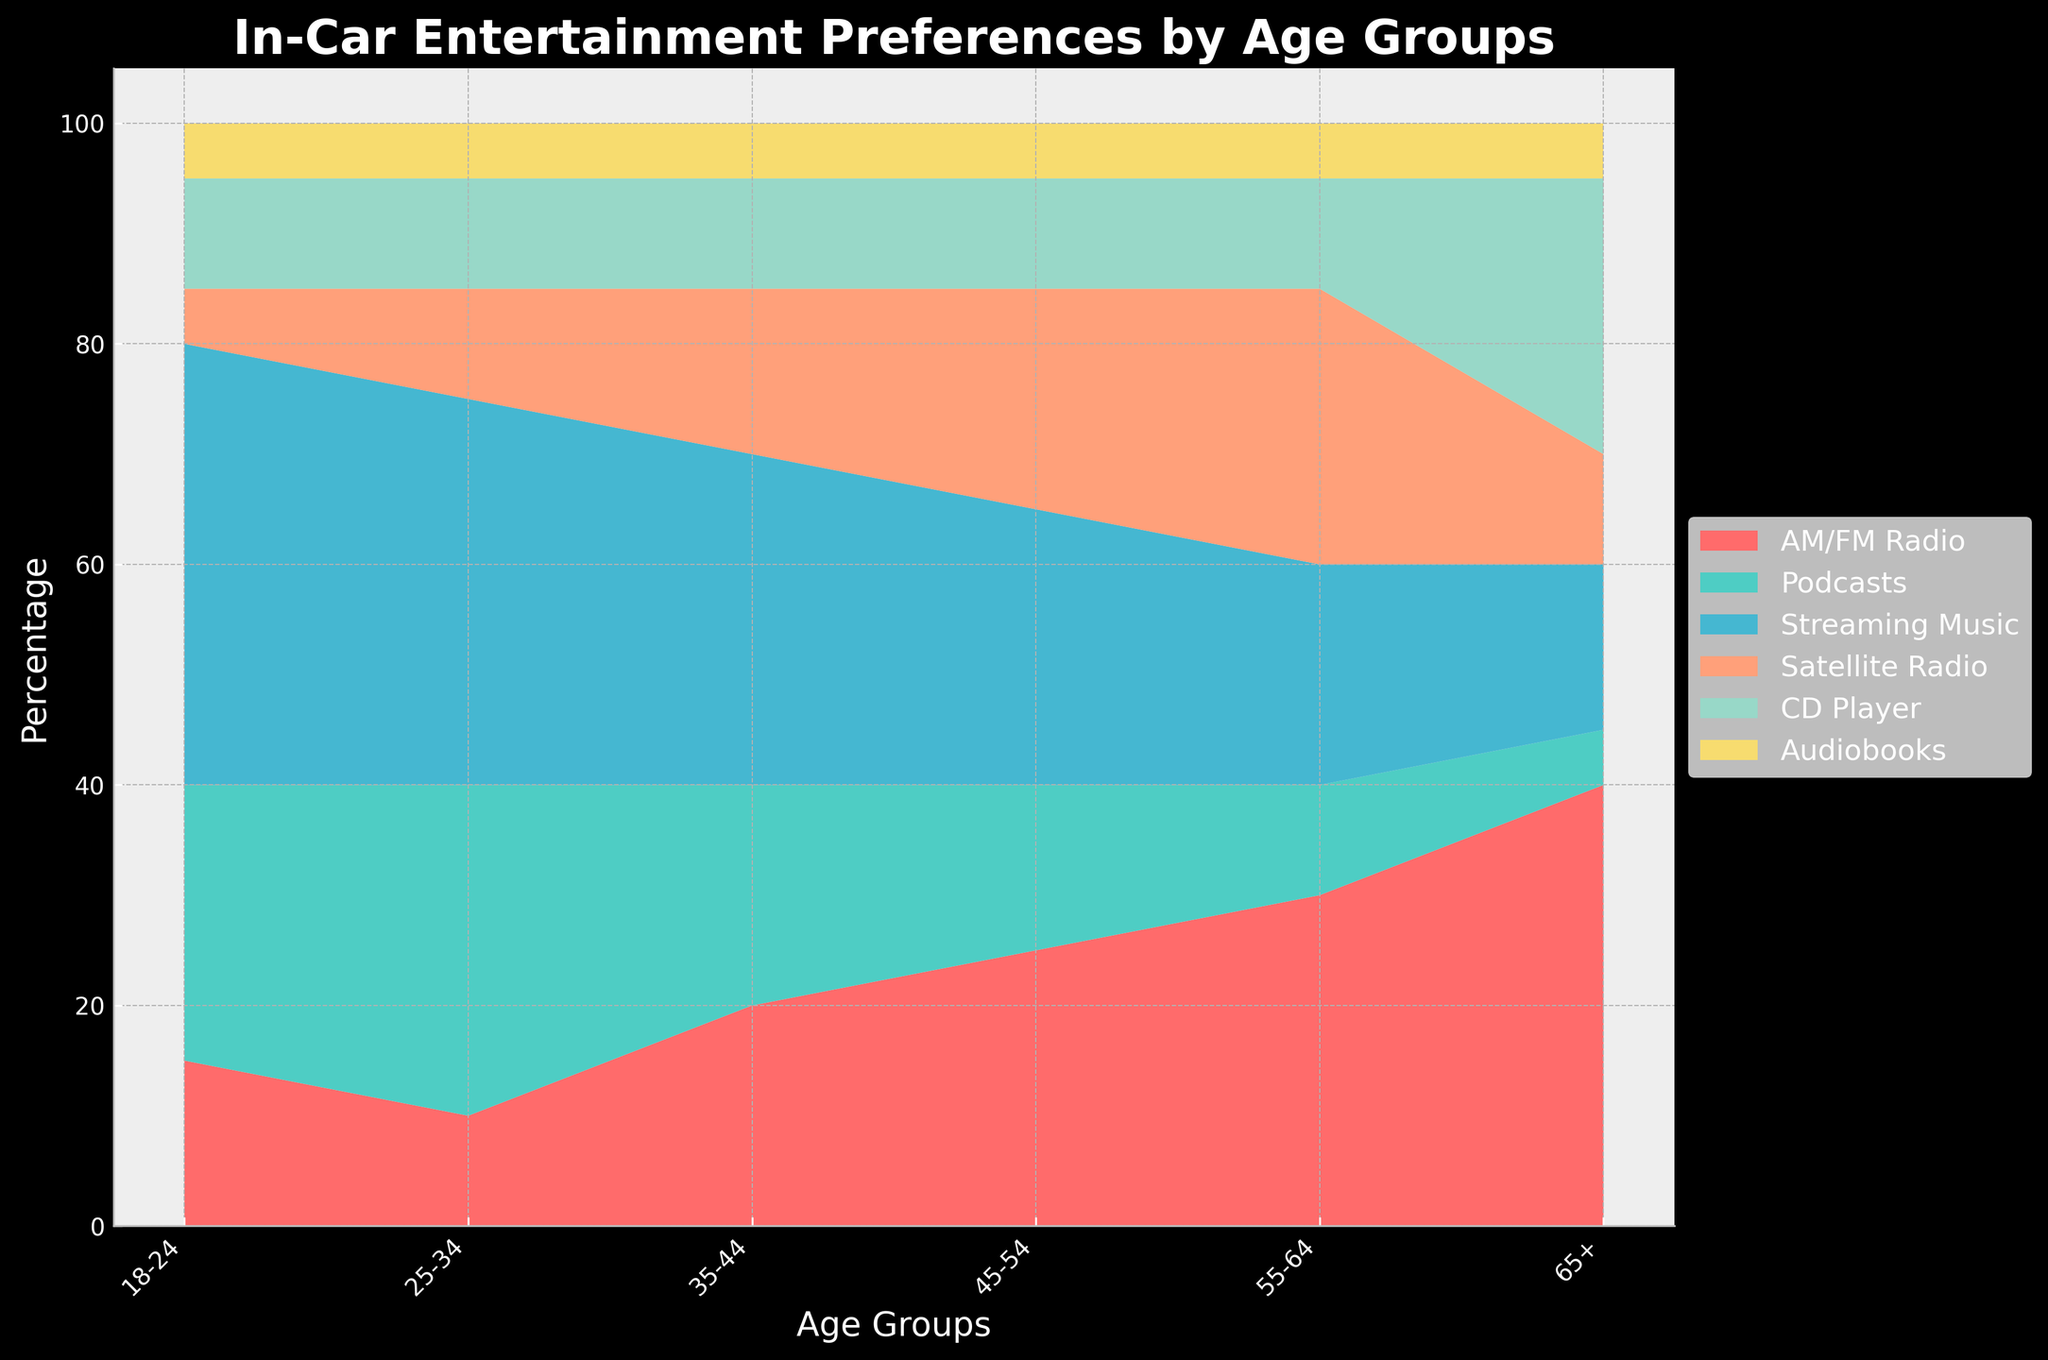What is the most popular in-car entertainment preference for the 18-24 age group? The Stream graph shows that Streaming Music has the highest percentage in the 18-24 age group. By observing the height of the different segments within the 18-24 age group section, Streaming Music appears highest.
Answer: Streaming Music Which age group has the highest preference for AM/FM Radio? The Stream graph shows AM/FM Radio preferences as colored regions. The largest region for AM/FM Radio is observed in the older age group, specifically 65+.
Answer: 65+ How does the preference for Satellite Radio change across age groups? By following the trajectory of the Satellite Radio segment's width across different age groups, it appears to increase with age but peaks around 55-64 before decreasing.
Answer: Increases then decreases Which age group prefers Podcasts the most? The labeled segments indicate Podcast preferences, and the largest segment for Podcasts is observed in the 25-34 age group.
Answer: 25-34 What is the combined preference percentage for Audiobooks across all age groups? Each age group has a 5% preference for Audiobooks (6 groups total). Summing these values gives 5% * 6 = 30%.
Answer: 30% Compare the preference for CD Players among the 18-24 and 65+ age groups. The Stream graph indicates both segments having the 10% preference. Both segments for CD Players appear to be of equal height in the 18-24 and 65+ age groups.
Answer: Equal What is the difference in preference percentage for Streaming Music between the 18-24 and 45-54 age groups? The 18-24 age group has 40% preference while the 45-54 age group has 25%. So, 40% - 25% = 15%.
Answer: 15% Identify the least popular in-car entertainment preference for the 35-44 age group. By observing the 35-44 section, the segment for Audiobooks is the smallest, indicating the least preference.
Answer: Audiobooks Which age group shows the most balanced preferences across all entertainment types? The 35-44 age group segment heights are more uniform compared to others, indicating no single preference is overly dominant.
Answer: 35-44 What's the trend of preference for AM/FM Radio from the youngest to the oldest age group? Observing the segment for AM/FM Radio across age groups, it increases continuously from 15% in the youngest group to 40% in the oldest.
Answer: Increases 